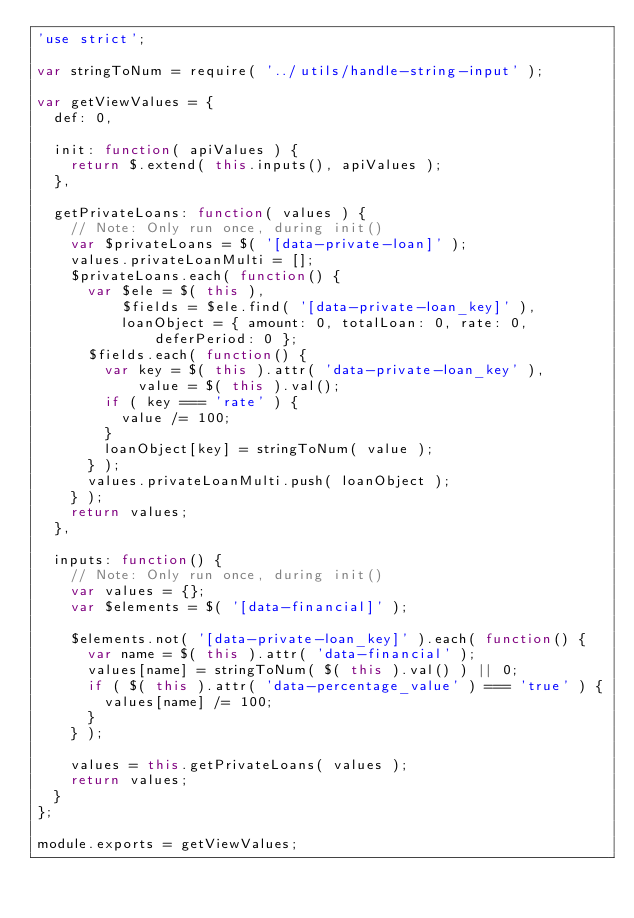Convert code to text. <code><loc_0><loc_0><loc_500><loc_500><_JavaScript_>'use strict';

var stringToNum = require( '../utils/handle-string-input' );

var getViewValues = {
  def: 0,

  init: function( apiValues ) {
    return $.extend( this.inputs(), apiValues );
  },

  getPrivateLoans: function( values ) {
    // Note: Only run once, during init()
    var $privateLoans = $( '[data-private-loan]' );
    values.privateLoanMulti = [];
    $privateLoans.each( function() {
      var $ele = $( this ),
          $fields = $ele.find( '[data-private-loan_key]' ),
          loanObject = { amount: 0, totalLoan: 0, rate: 0, deferPeriod: 0 };
      $fields.each( function() {
        var key = $( this ).attr( 'data-private-loan_key' ),
            value = $( this ).val();
        if ( key === 'rate' ) {
          value /= 100;
        }
        loanObject[key] = stringToNum( value );
      } );
      values.privateLoanMulti.push( loanObject );
    } );
    return values;
  },

  inputs: function() {
    // Note: Only run once, during init()
    var values = {};
    var $elements = $( '[data-financial]' );

    $elements.not( '[data-private-loan_key]' ).each( function() {
      var name = $( this ).attr( 'data-financial' );
      values[name] = stringToNum( $( this ).val() ) || 0;
      if ( $( this ).attr( 'data-percentage_value' ) === 'true' ) {
        values[name] /= 100;
      }
    } );

    values = this.getPrivateLoans( values );
    return values;
  }
};

module.exports = getViewValues;
</code> 